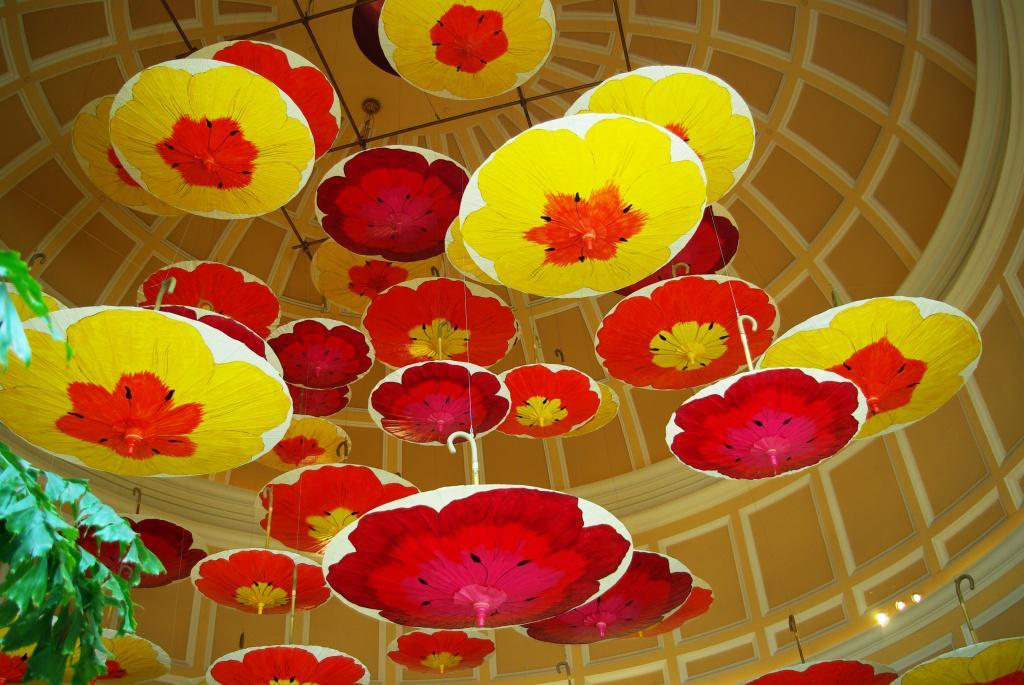What objects are hanging on the roof top in the image? There are umbrellas hanging on the roof top in the image. What can be seen on the left side of the image? There are leaves visible on the left side of the image. How many stomachs can be seen in the image? There are no stomachs visible in the image. What type of knife is being used to cut the leaves in the image? There is no knife present in the image, and the leaves are not being cut. 